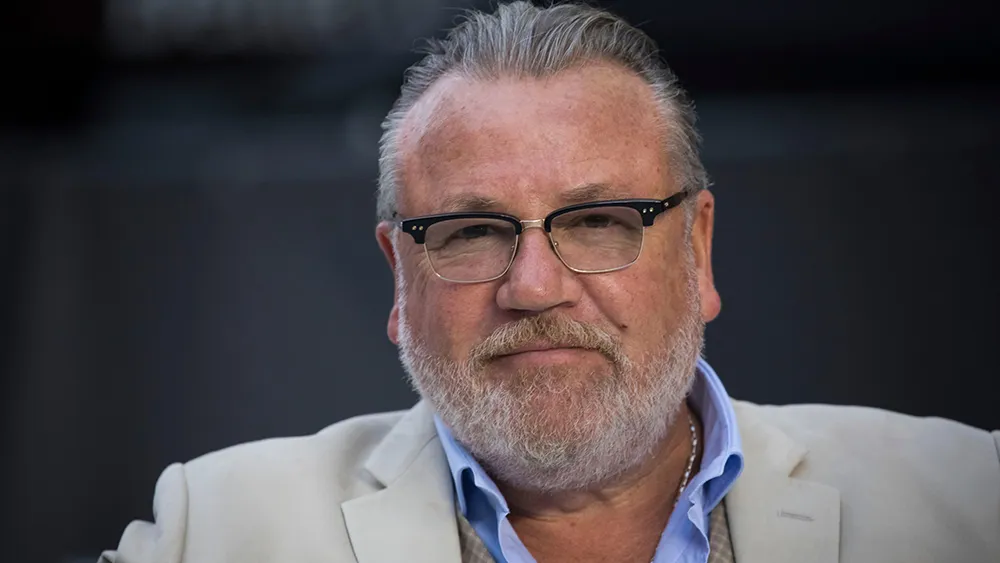What might the person in the image be thinking about? The subject's pensive expression and distant gaze suggest he may be pondering a significant decision or reflecting on a poignant memory. His serious demeanor indicates that his thoughts are likely of considerable importance to him, perhaps related to his career or personal life. 